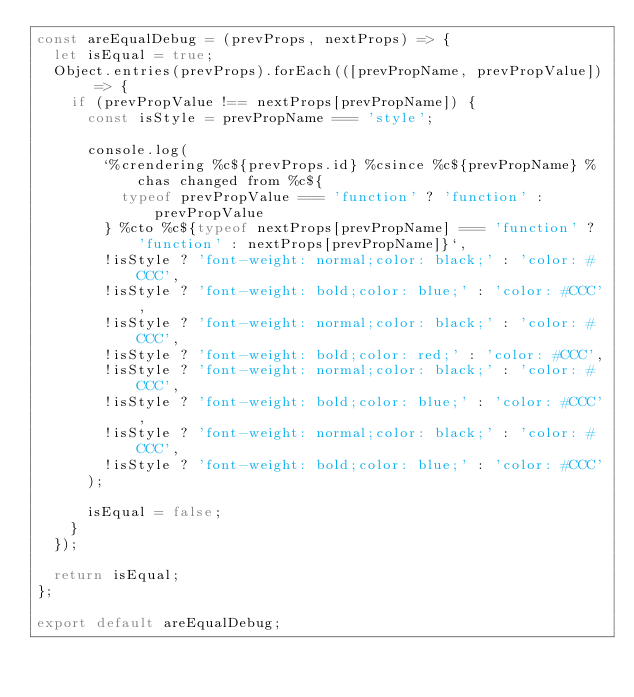Convert code to text. <code><loc_0><loc_0><loc_500><loc_500><_JavaScript_>const areEqualDebug = (prevProps, nextProps) => {
  let isEqual = true;
  Object.entries(prevProps).forEach(([prevPropName, prevPropValue]) => {
    if (prevPropValue !== nextProps[prevPropName]) {
      const isStyle = prevPropName === 'style';

      console.log(
        `%crendering %c${prevProps.id} %csince %c${prevPropName} %chas changed from %c${
          typeof prevPropValue === 'function' ? 'function' : prevPropValue
        } %cto %c${typeof nextProps[prevPropName] === 'function' ? 'function' : nextProps[prevPropName]}`,
        !isStyle ? 'font-weight: normal;color: black;' : 'color: #CCC',
        !isStyle ? 'font-weight: bold;color: blue;' : 'color: #CCC',
        !isStyle ? 'font-weight: normal;color: black;' : 'color: #CCC',
        !isStyle ? 'font-weight: bold;color: red;' : 'color: #CCC',
        !isStyle ? 'font-weight: normal;color: black;' : 'color: #CCC',
        !isStyle ? 'font-weight: bold;color: blue;' : 'color: #CCC',
        !isStyle ? 'font-weight: normal;color: black;' : 'color: #CCC',
        !isStyle ? 'font-weight: bold;color: blue;' : 'color: #CCC'
      );

      isEqual = false;
    }
  });

  return isEqual;
};

export default areEqualDebug;
</code> 